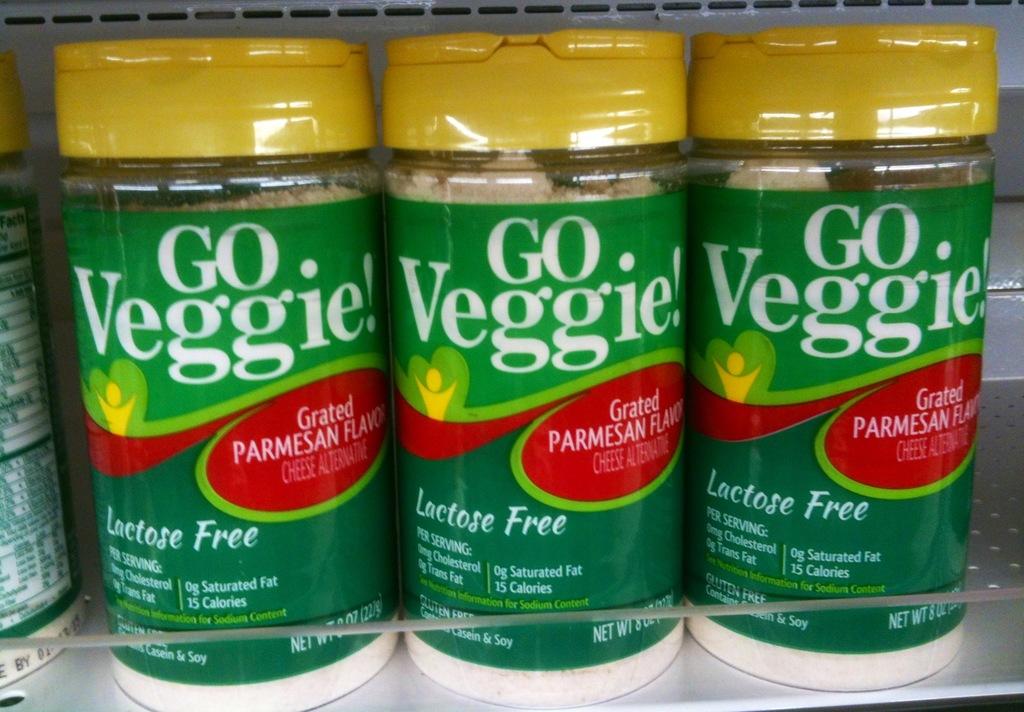What is the container free of?
Your answer should be very brief. Lactose. What is the brand inscribed on the container?
Give a very brief answer. Go veggie!. 